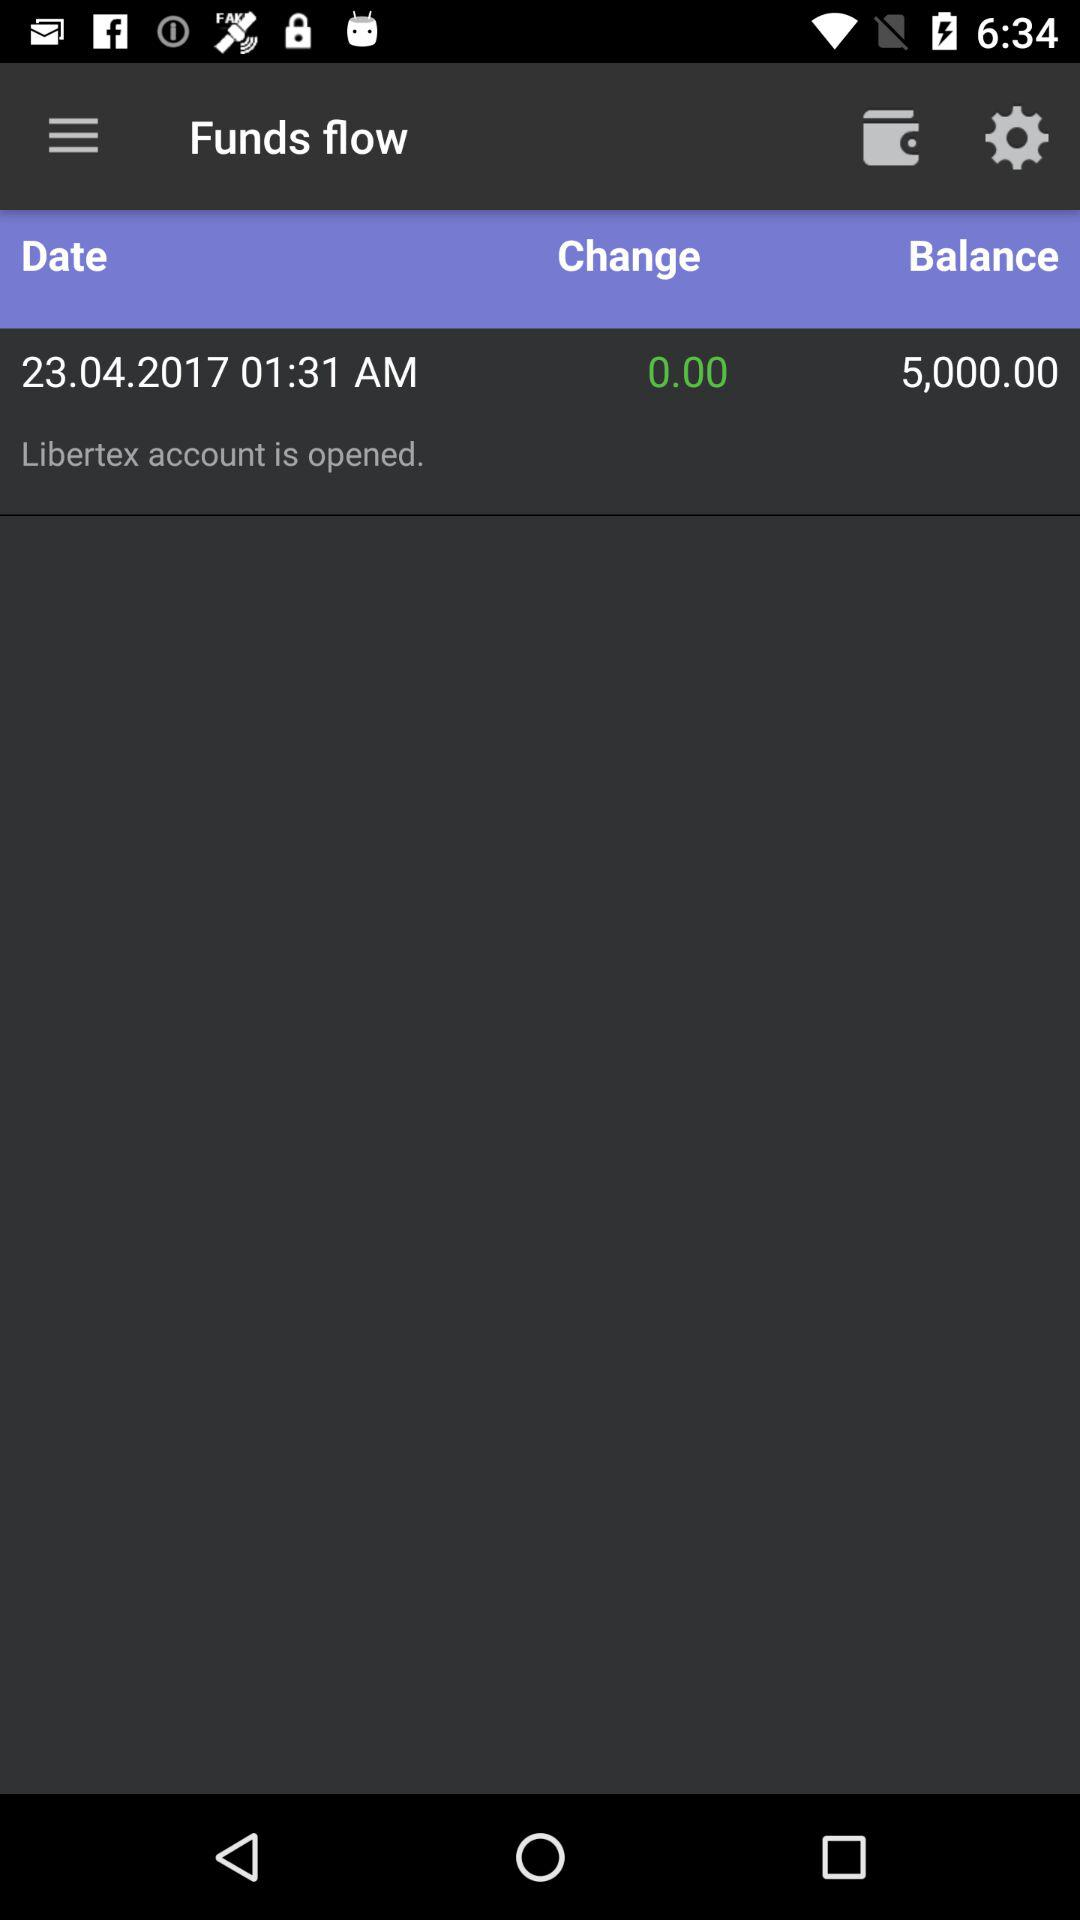What is the balance? The balance is 5,000. 